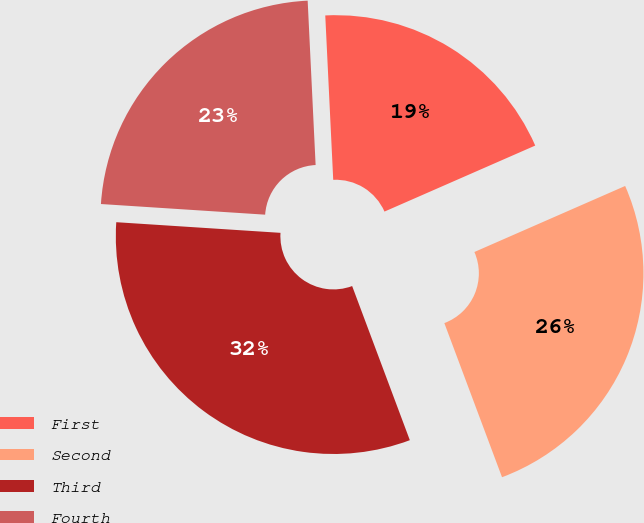Convert chart to OTSL. <chart><loc_0><loc_0><loc_500><loc_500><pie_chart><fcel>First<fcel>Second<fcel>Third<fcel>Fourth<nl><fcel>19.2%<fcel>25.87%<fcel>31.73%<fcel>23.2%<nl></chart> 